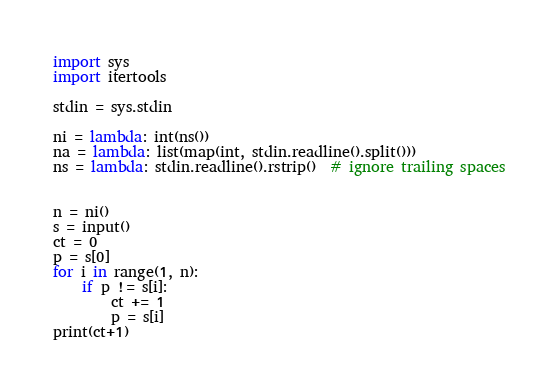<code> <loc_0><loc_0><loc_500><loc_500><_Python_>import sys
import itertools

stdin = sys.stdin

ni = lambda: int(ns())
na = lambda: list(map(int, stdin.readline().split()))
ns = lambda: stdin.readline().rstrip()  # ignore trailing spaces


n = ni()
s = input()
ct = 0
p = s[0]
for i in range(1, n):
    if p != s[i]:
        ct += 1
        p = s[i]
print(ct+1)


</code> 